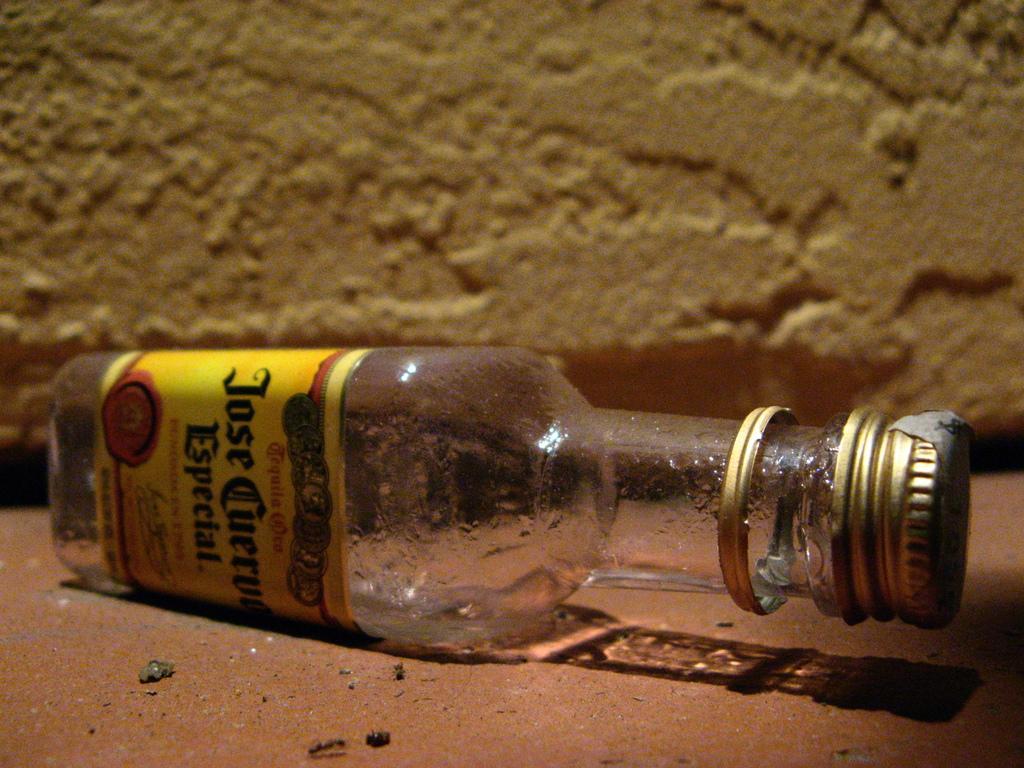Can you describe this image briefly? In this image, there is a bottle. it has a label and contains some text. There is a wall behind this bottle. 